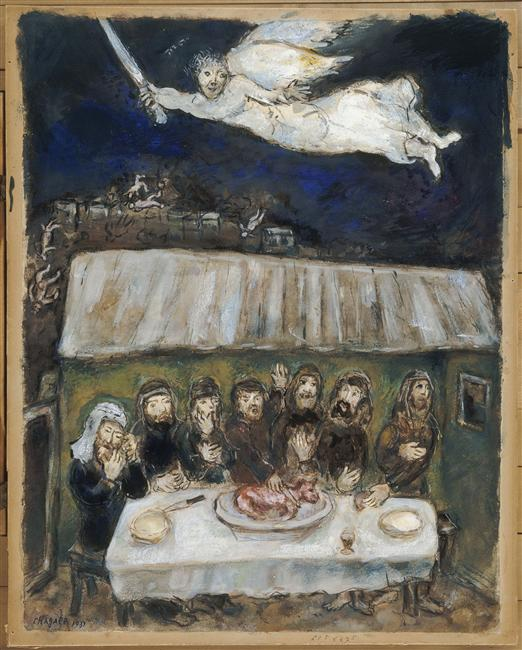Imagine the scene continues. What might happen next? In the next moments, the angel-like figure might descend towards the gathered people, perhaps imparting a message or blessing to them. The group, in turn, could react with awe and respect, possibly receiving guidance or instructions. Alternatively, a ritual or ceremony might begin, with the piece of meat at the table's center playing a central role in their actions. 